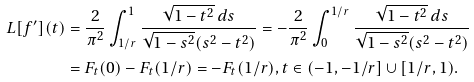Convert formula to latex. <formula><loc_0><loc_0><loc_500><loc_500>L [ f ^ { \prime } ] ( t ) & = \frac { 2 } { \pi ^ { 2 } } \int _ { 1 / r } ^ { 1 } \frac { \sqrt { 1 - t ^ { 2 } } \, d s } { \sqrt { 1 - s ^ { 2 } } ( s ^ { 2 } - t ^ { 2 } ) } = - \frac { 2 } { \pi ^ { 2 } } \int _ { 0 } ^ { 1 / r } \frac { \sqrt { 1 - t ^ { 2 } } \, d s } { \sqrt { 1 - s ^ { 2 } } ( s ^ { 2 } - t ^ { 2 } ) } \\ & = F _ { t } ( 0 ) - F _ { t } ( 1 / r ) = - F _ { t } ( 1 / r ) , t \in ( - 1 , - 1 / r ] \cup [ 1 / r , 1 ) .</formula> 